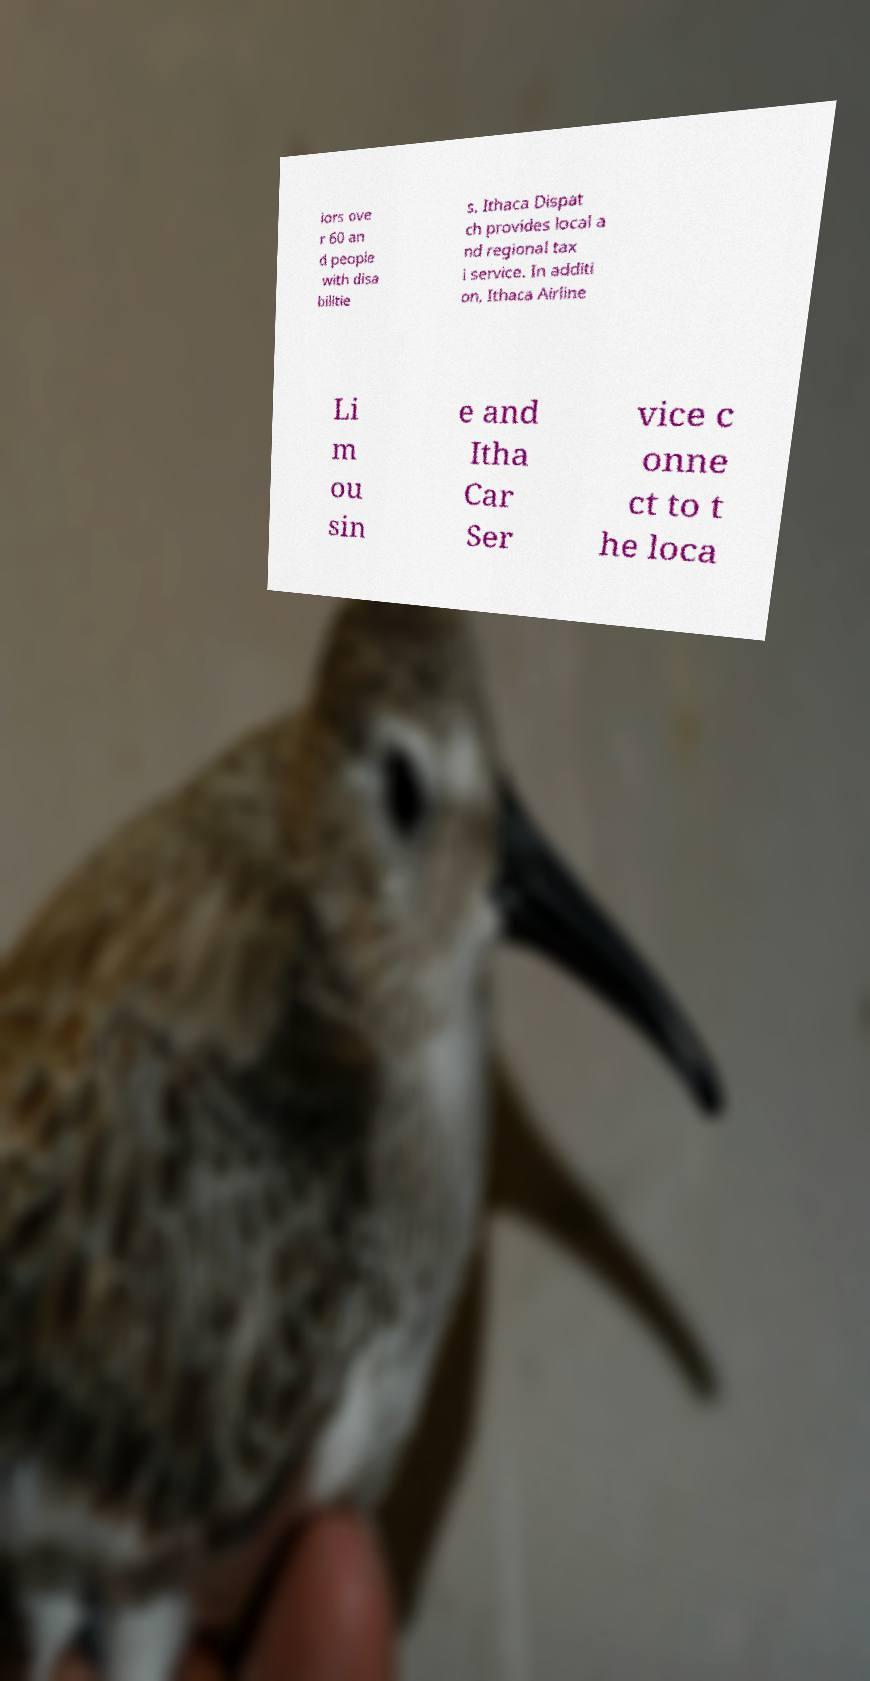What messages or text are displayed in this image? I need them in a readable, typed format. iors ove r 60 an d people with disa bilitie s. Ithaca Dispat ch provides local a nd regional tax i service. In additi on, Ithaca Airline Li m ou sin e and Itha Car Ser vice c onne ct to t he loca 